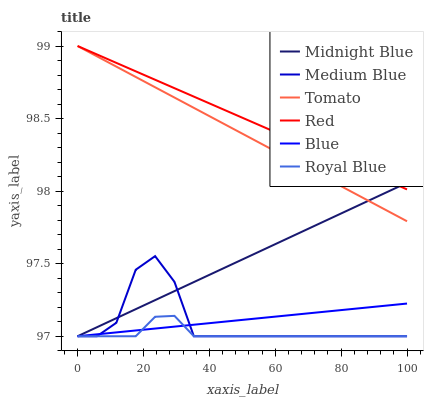Does Royal Blue have the minimum area under the curve?
Answer yes or no. Yes. Does Red have the maximum area under the curve?
Answer yes or no. Yes. Does Blue have the minimum area under the curve?
Answer yes or no. No. Does Blue have the maximum area under the curve?
Answer yes or no. No. Is Midnight Blue the smoothest?
Answer yes or no. Yes. Is Medium Blue the roughest?
Answer yes or no. Yes. Is Blue the smoothest?
Answer yes or no. No. Is Blue the roughest?
Answer yes or no. No. Does Blue have the lowest value?
Answer yes or no. Yes. Does Red have the lowest value?
Answer yes or no. No. Does Red have the highest value?
Answer yes or no. Yes. Does Blue have the highest value?
Answer yes or no. No. Is Royal Blue less than Red?
Answer yes or no. Yes. Is Red greater than Royal Blue?
Answer yes or no. Yes. Does Blue intersect Midnight Blue?
Answer yes or no. Yes. Is Blue less than Midnight Blue?
Answer yes or no. No. Is Blue greater than Midnight Blue?
Answer yes or no. No. Does Royal Blue intersect Red?
Answer yes or no. No. 